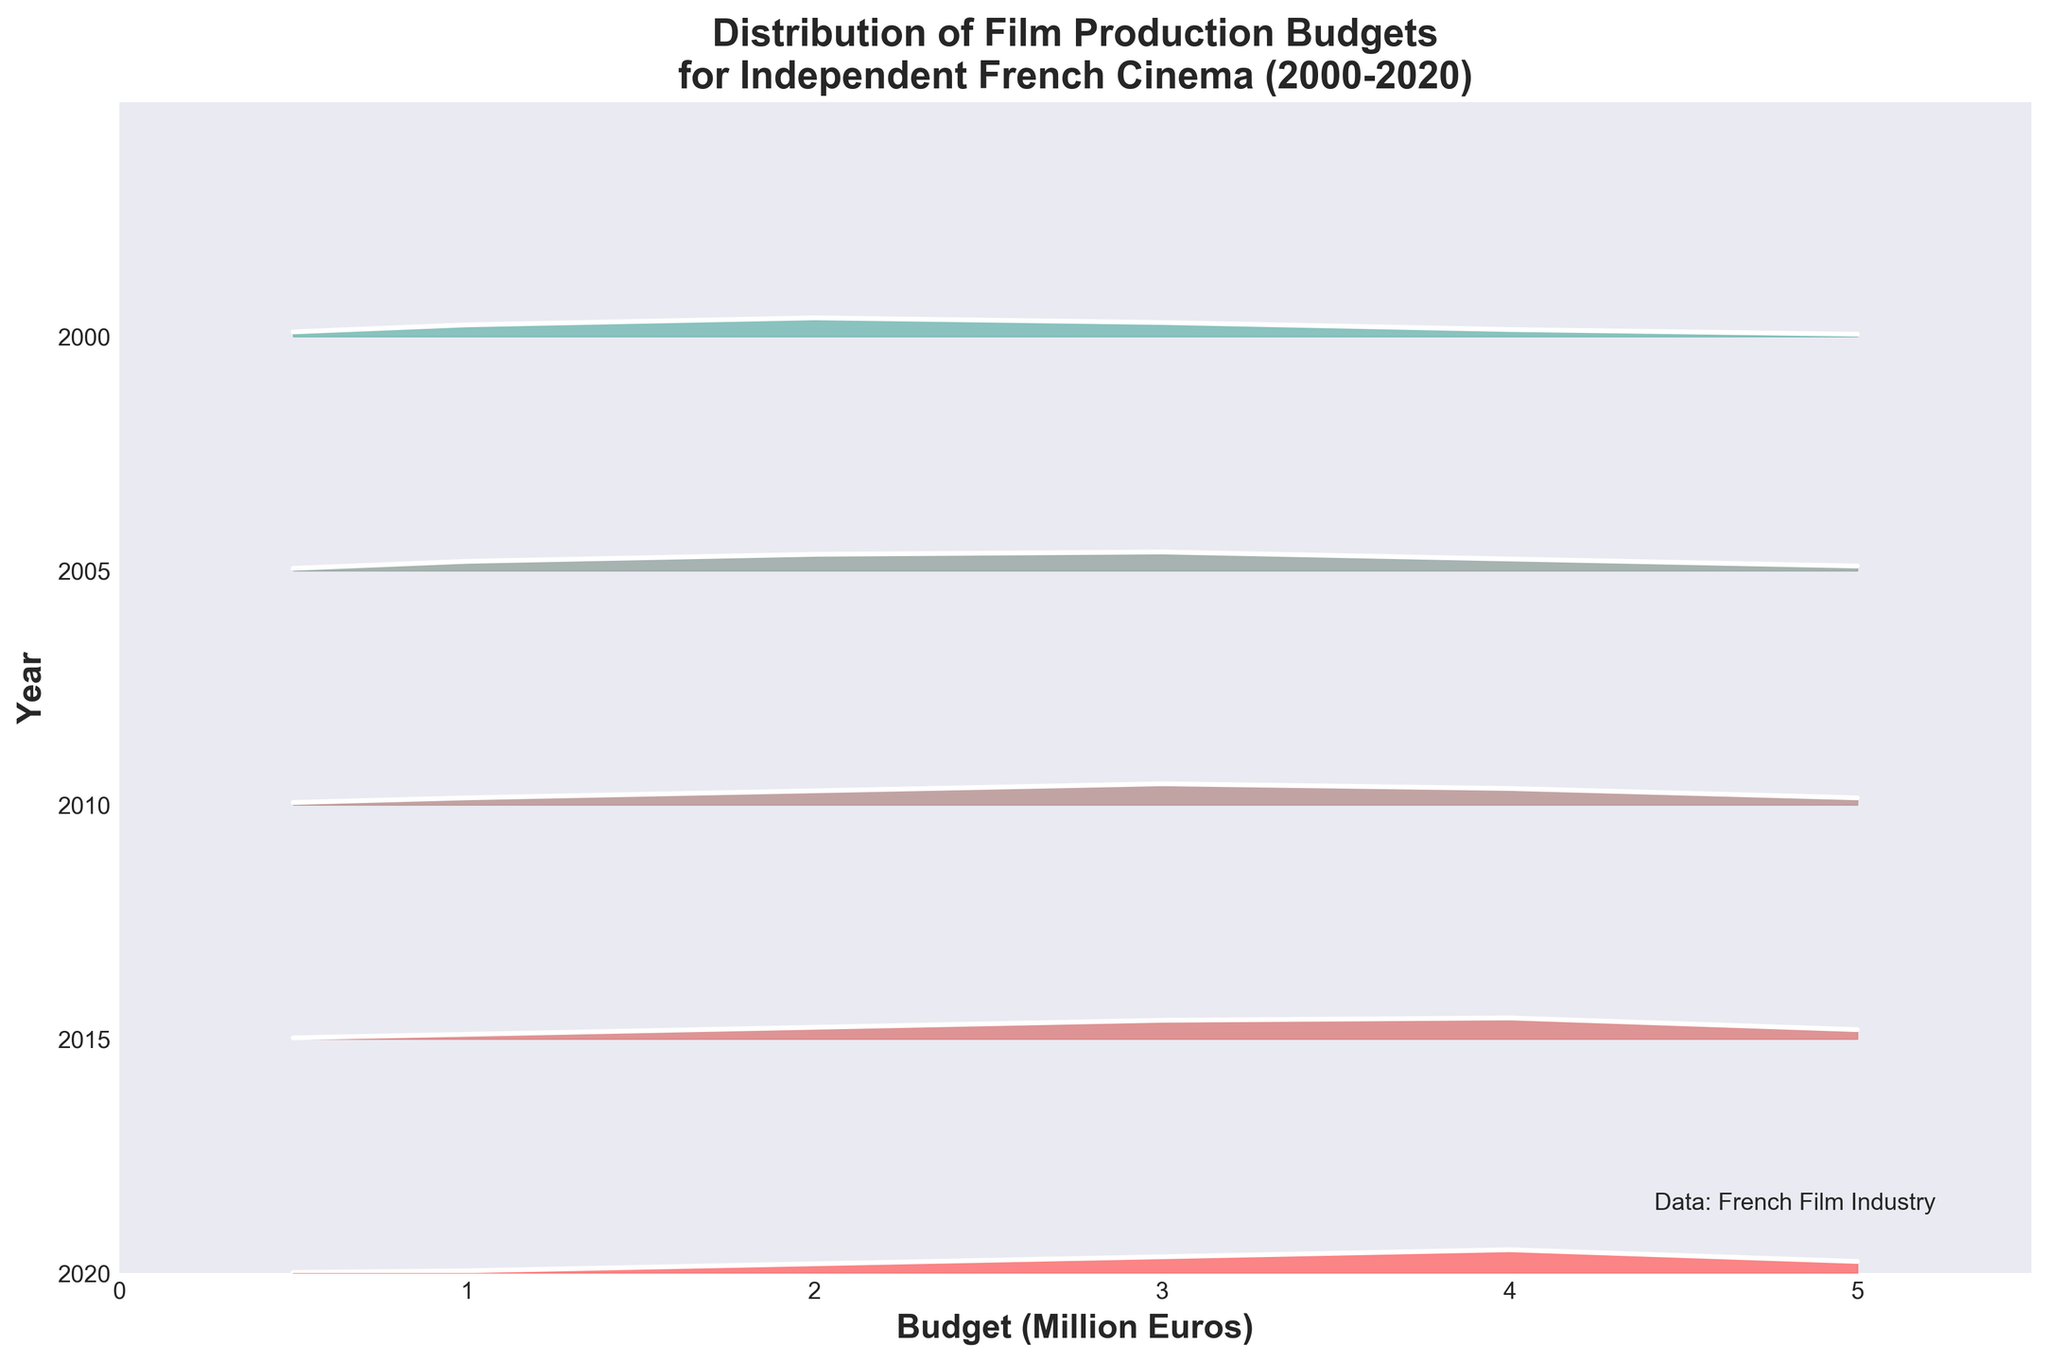What is the title of the plot? The title is typically found at the top of the figure, usually in larger or bold font. It provides a summary of the major theme or focus of the plot. In this case, it states "Distribution of Film Production Budgets for Independent French Cinema (2000-2020)"
Answer: Distribution of Film Production Budgets for Independent French Cinema (2000-2020) What is the range of the budget axis? The budget axis (x-axis) typically runs along the bottom of the plot. Its range is indicated by the numerical scale provided. Here, the budget ranges from 0 to 5.5 million Euros.
Answer: 0 to 5.5 million Euros Which year has the highest density for a budget of 3 million Euros? The densest part of the Ridgeline plot for each year will peak at different budgets. We can compare the height of the peaks at 3 million Euros across the years. In this plot, the year 2010 shows the highest density at the 3 million Euros budget.
Answer: 2010 How does the density of budgets evolve from 2000 to 2020? Observing the plot from bottom to top (older to more recent years), we can notice the shifts in peaks and densities. Over time, the density becomes more spread out, indicating varied budgets, with an increasing density concentrated around higher budgets (3-5 million Euros) as years progress.
Answer: Densities become more spread out with increased concentration on higher budgets (3-5 million) Which year shows the highest density at the 4 million Euros budget? By examining the peaks at the 4 million Euros budget for each year, we see that in 2020, there is a significant peak, indicating the highest density compared to other years.
Answer: 2020 What are the y-axis labels in the plot? Y-axis labels typically run along the vertical axis of the plot. They indicate the different years being compared. Here, the labels are the years from 2000 to 2020.
Answer: 2000, 2005, 2010, 2015, 2020 Between which years did the highest budget density shift from 2 million Euros to 3 million Euros? By examining the peak shifts along the timeline, we can observe that in 2000, the peak density is at 2 million Euros. By 2005, this peak shifts to 3 million Euros. This indicates the highest budget density shift occurred between these two years.
Answer: Between 2000 and 2005 What trend can be observed in the density distribution of lower budgets (0.5 to 1 million Euros) over the years? Lower budgets' densities (0.5 to 1 million Euros) can be tracked across years by following their corresponding positions on the x-axis. We notice that the densities for these lower budgets decrease over the years, showing more independent films having larger budgets.
Answer: Decreasing density Which year had the lowest density at the highest budget point (5 million Euros)? To determine this, we can look at the 5 million Euros mark and compare densities across years. The year 2000 shows the lowest density at this budget point.
Answer: 2000 